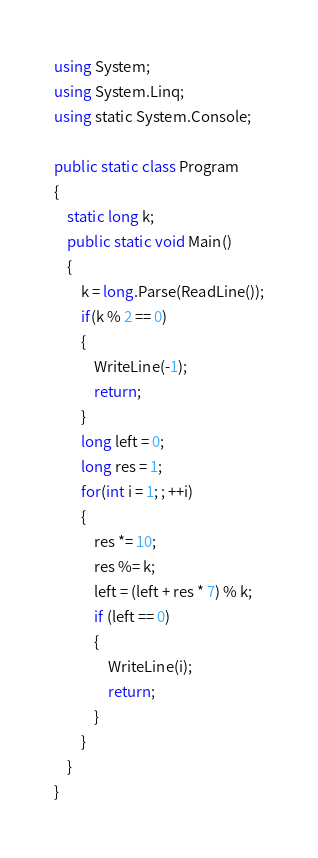Convert code to text. <code><loc_0><loc_0><loc_500><loc_500><_C#_>using System;
using System.Linq;
using static System.Console;

public static class Program
{
    static long k;
    public static void Main()
    {
        k = long.Parse(ReadLine());
        if(k % 2 == 0)
        {
            WriteLine(-1);
            return;
        }
        long left = 0;
        long res = 1;
        for(int i = 1; ; ++i)
        {
            res *= 10;
            res %= k;
            left = (left + res * 7) % k;
            if (left == 0)
            {
                WriteLine(i);
                return;
            }
        }
    }
}</code> 